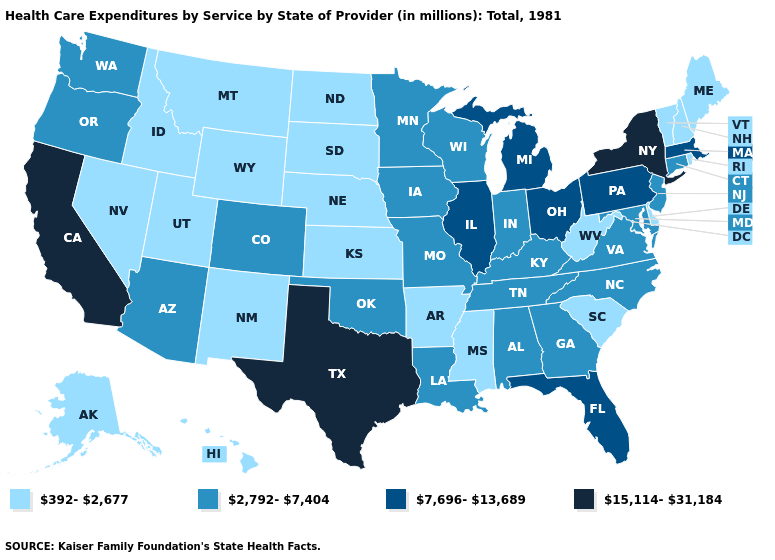Which states have the highest value in the USA?
Quick response, please. California, New York, Texas. What is the value of Connecticut?
Quick response, please. 2,792-7,404. Name the states that have a value in the range 7,696-13,689?
Concise answer only. Florida, Illinois, Massachusetts, Michigan, Ohio, Pennsylvania. What is the highest value in the USA?
Write a very short answer. 15,114-31,184. What is the value of Wisconsin?
Answer briefly. 2,792-7,404. Is the legend a continuous bar?
Write a very short answer. No. What is the value of Mississippi?
Answer briefly. 392-2,677. Among the states that border Utah , does New Mexico have the highest value?
Give a very brief answer. No. Among the states that border Washington , which have the lowest value?
Short answer required. Idaho. Name the states that have a value in the range 392-2,677?
Answer briefly. Alaska, Arkansas, Delaware, Hawaii, Idaho, Kansas, Maine, Mississippi, Montana, Nebraska, Nevada, New Hampshire, New Mexico, North Dakota, Rhode Island, South Carolina, South Dakota, Utah, Vermont, West Virginia, Wyoming. Does Colorado have a higher value than New Hampshire?
Answer briefly. Yes. Does the first symbol in the legend represent the smallest category?
Quick response, please. Yes. What is the value of Maryland?
Answer briefly. 2,792-7,404. Name the states that have a value in the range 15,114-31,184?
Give a very brief answer. California, New York, Texas. What is the highest value in the Northeast ?
Give a very brief answer. 15,114-31,184. 